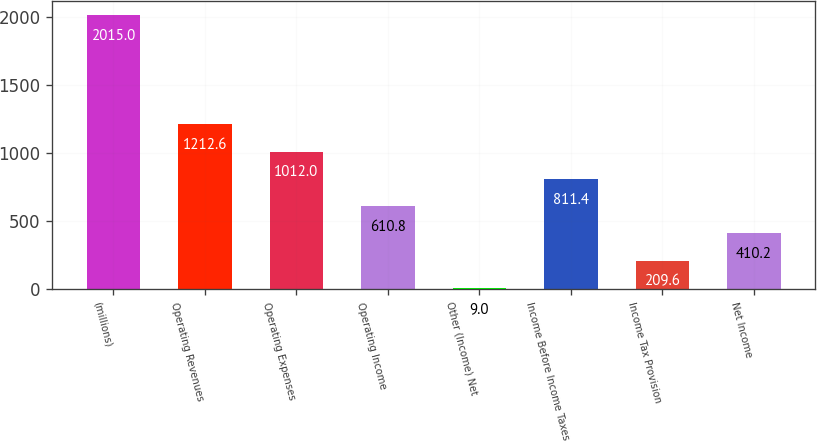Convert chart to OTSL. <chart><loc_0><loc_0><loc_500><loc_500><bar_chart><fcel>(millions)<fcel>Operating Revenues<fcel>Operating Expenses<fcel>Operating Income<fcel>Other (Income) Net<fcel>Income Before Income Taxes<fcel>Income Tax Provision<fcel>Net Income<nl><fcel>2015<fcel>1212.6<fcel>1012<fcel>610.8<fcel>9<fcel>811.4<fcel>209.6<fcel>410.2<nl></chart> 